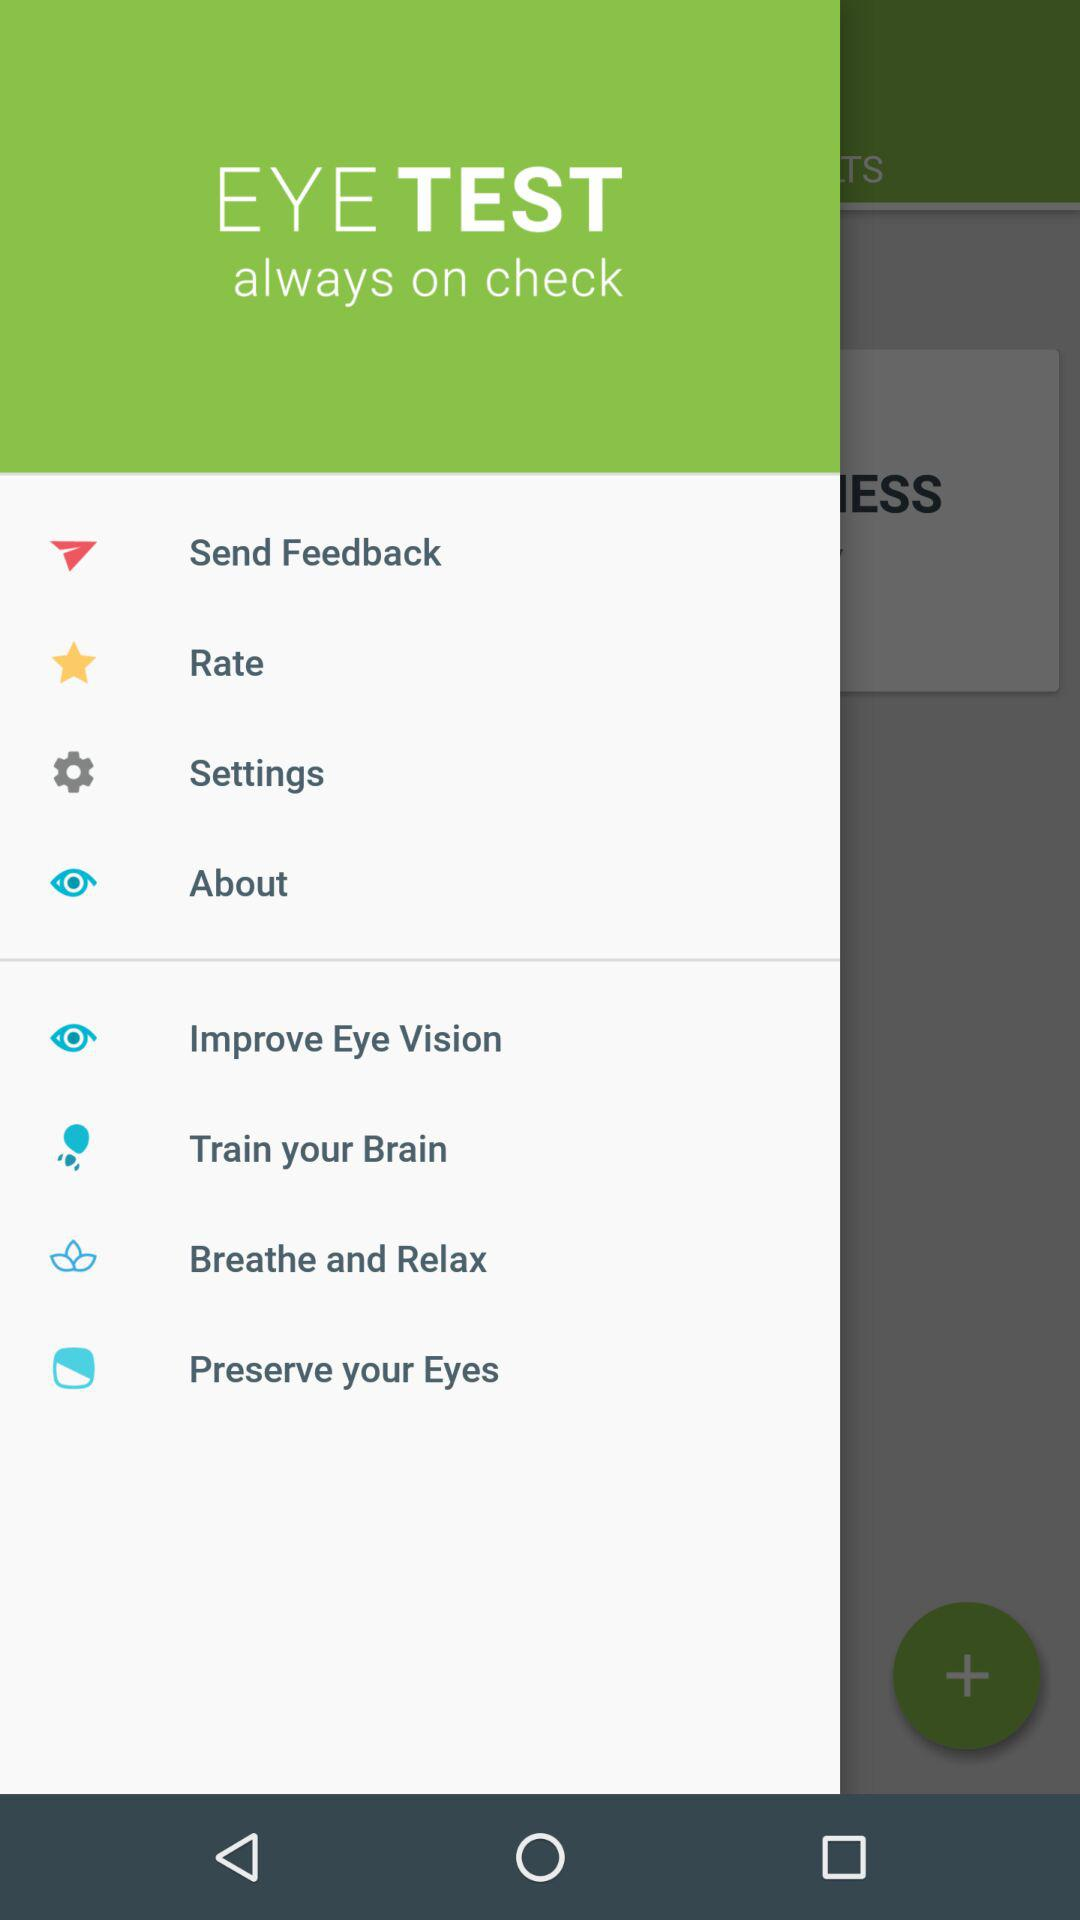What is the application name? The application name is "EYE TEST". 